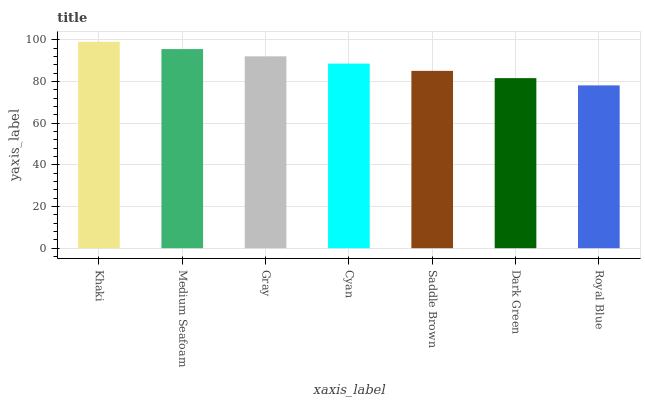Is Royal Blue the minimum?
Answer yes or no. Yes. Is Khaki the maximum?
Answer yes or no. Yes. Is Medium Seafoam the minimum?
Answer yes or no. No. Is Medium Seafoam the maximum?
Answer yes or no. No. Is Khaki greater than Medium Seafoam?
Answer yes or no. Yes. Is Medium Seafoam less than Khaki?
Answer yes or no. Yes. Is Medium Seafoam greater than Khaki?
Answer yes or no. No. Is Khaki less than Medium Seafoam?
Answer yes or no. No. Is Cyan the high median?
Answer yes or no. Yes. Is Cyan the low median?
Answer yes or no. Yes. Is Medium Seafoam the high median?
Answer yes or no. No. Is Dark Green the low median?
Answer yes or no. No. 